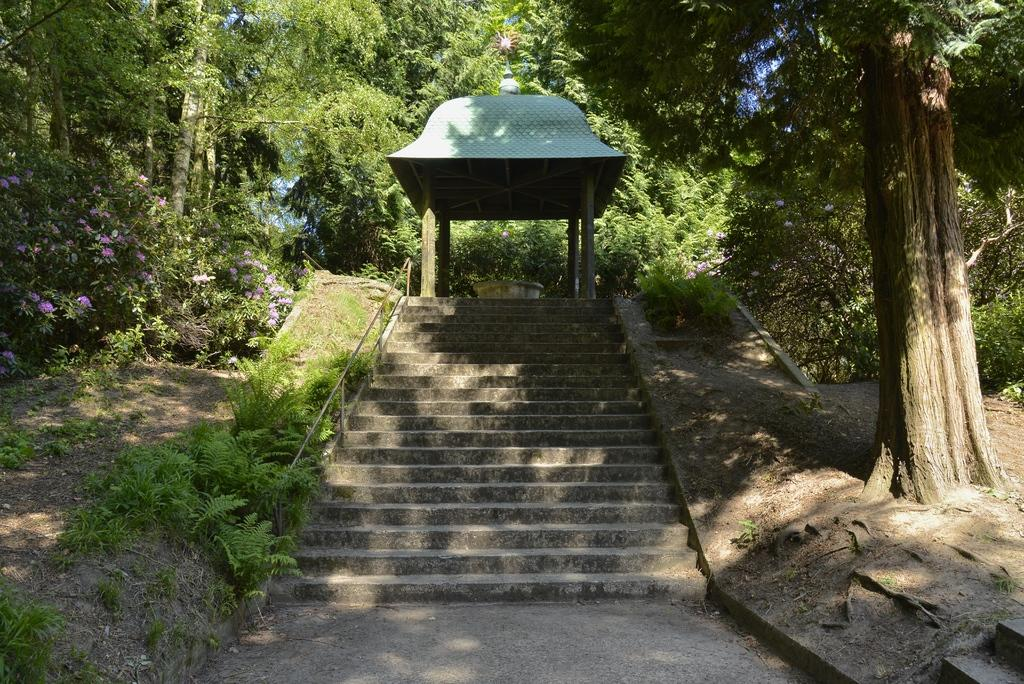What type of architectural feature is present in the image? There are stairs in the image. What other elements can be seen in the image? There are plants and a pergola in the image. What can be seen in the background of the image? Trees are present in the background of the image. What type of oatmeal is being served for dinner in the image? There is no oatmeal or dinner present in the image. What type of home is depicted in the image? The image does not depict a home; it features stairs, plants, a pergola, and trees. 